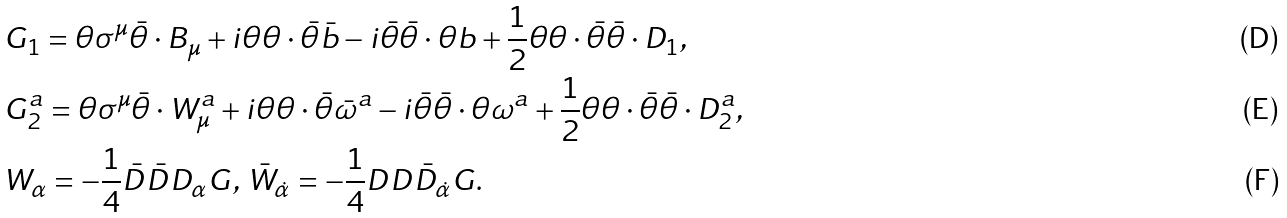<formula> <loc_0><loc_0><loc_500><loc_500>& G _ { 1 } = \theta \sigma ^ { \mu } \bar { \theta } \cdot B _ { \mu } + i \theta \theta \cdot \bar { \theta } \bar { b } - i \bar { \theta } \bar { \theta } \cdot \theta b + \frac { 1 } { 2 } \theta \theta \cdot \bar { \theta } \bar { \theta } \cdot D _ { 1 } , \\ & G ^ { a } _ { 2 } = \theta \sigma ^ { \mu } \bar { \theta } \cdot W ^ { a } _ { \mu } + i \theta \theta \cdot \bar { \theta } \bar { \omega } ^ { a } - i \bar { \theta } \bar { \theta } \cdot \theta \omega ^ { a } + \frac { 1 } { 2 } \theta \theta \cdot \bar { \theta } \bar { \theta } \cdot D ^ { a } _ { 2 } , \\ & W _ { \alpha } = - \frac { 1 } { 4 } \bar { D } \bar { D } D _ { \alpha } G , \, \bar { W } _ { \dot { \alpha } } = - \frac { 1 } { 4 } D D \bar { D } _ { \dot { \alpha } } G .</formula> 